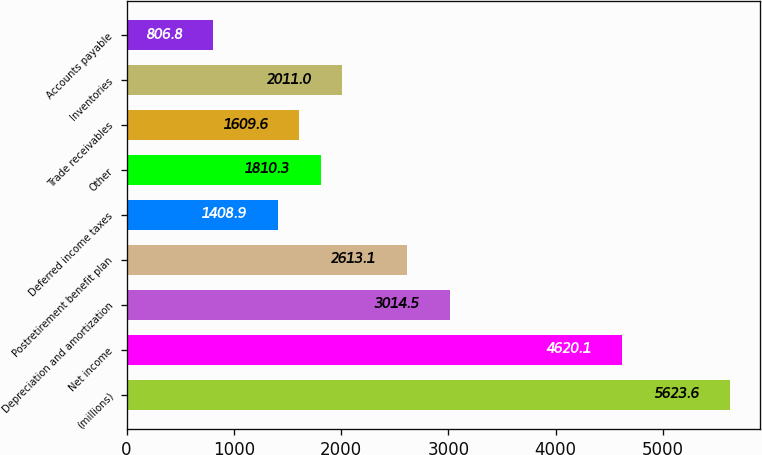Convert chart to OTSL. <chart><loc_0><loc_0><loc_500><loc_500><bar_chart><fcel>(millions)<fcel>Net income<fcel>Depreciation and amortization<fcel>Postretirement benefit plan<fcel>Deferred income taxes<fcel>Other<fcel>Trade receivables<fcel>Inventories<fcel>Accounts payable<nl><fcel>5623.6<fcel>4620.1<fcel>3014.5<fcel>2613.1<fcel>1408.9<fcel>1810.3<fcel>1609.6<fcel>2011<fcel>806.8<nl></chart> 